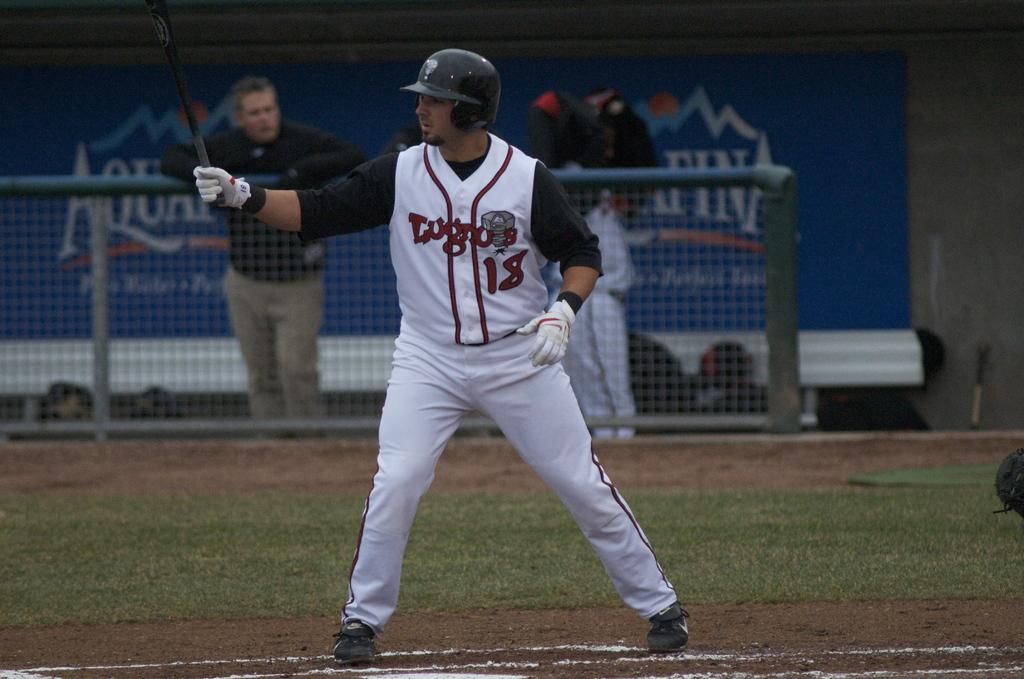<image>
Offer a succinct explanation of the picture presented. A baseball player is getting ready to bat wearing a jersey with the number 18 on it and while a man leaning on a fence watches 